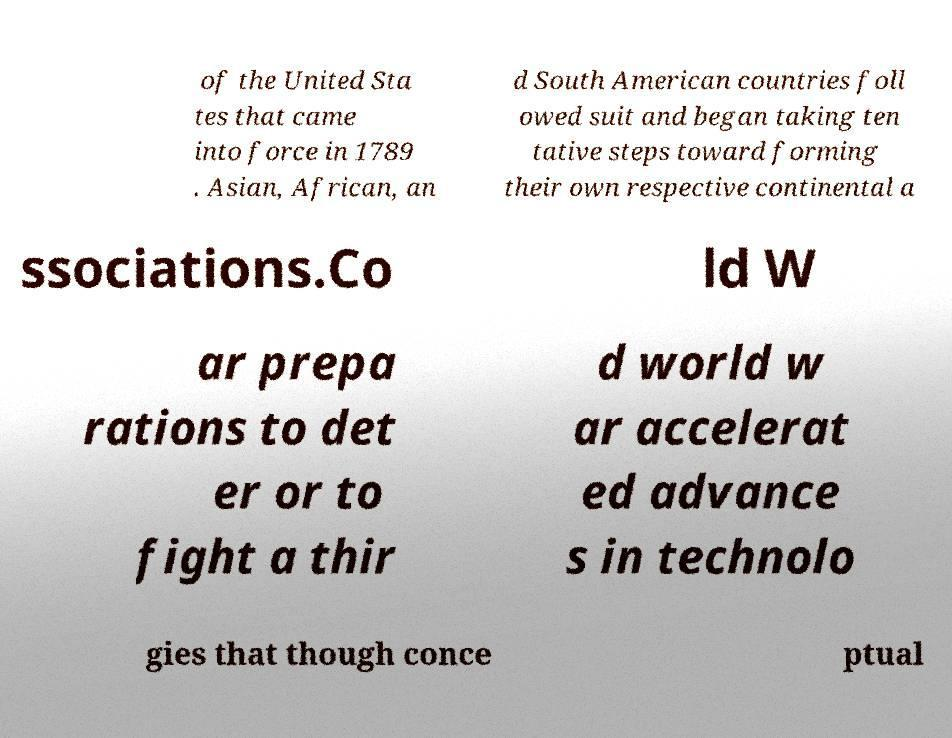Please read and relay the text visible in this image. What does it say? of the United Sta tes that came into force in 1789 . Asian, African, an d South American countries foll owed suit and began taking ten tative steps toward forming their own respective continental a ssociations.Co ld W ar prepa rations to det er or to fight a thir d world w ar accelerat ed advance s in technolo gies that though conce ptual 